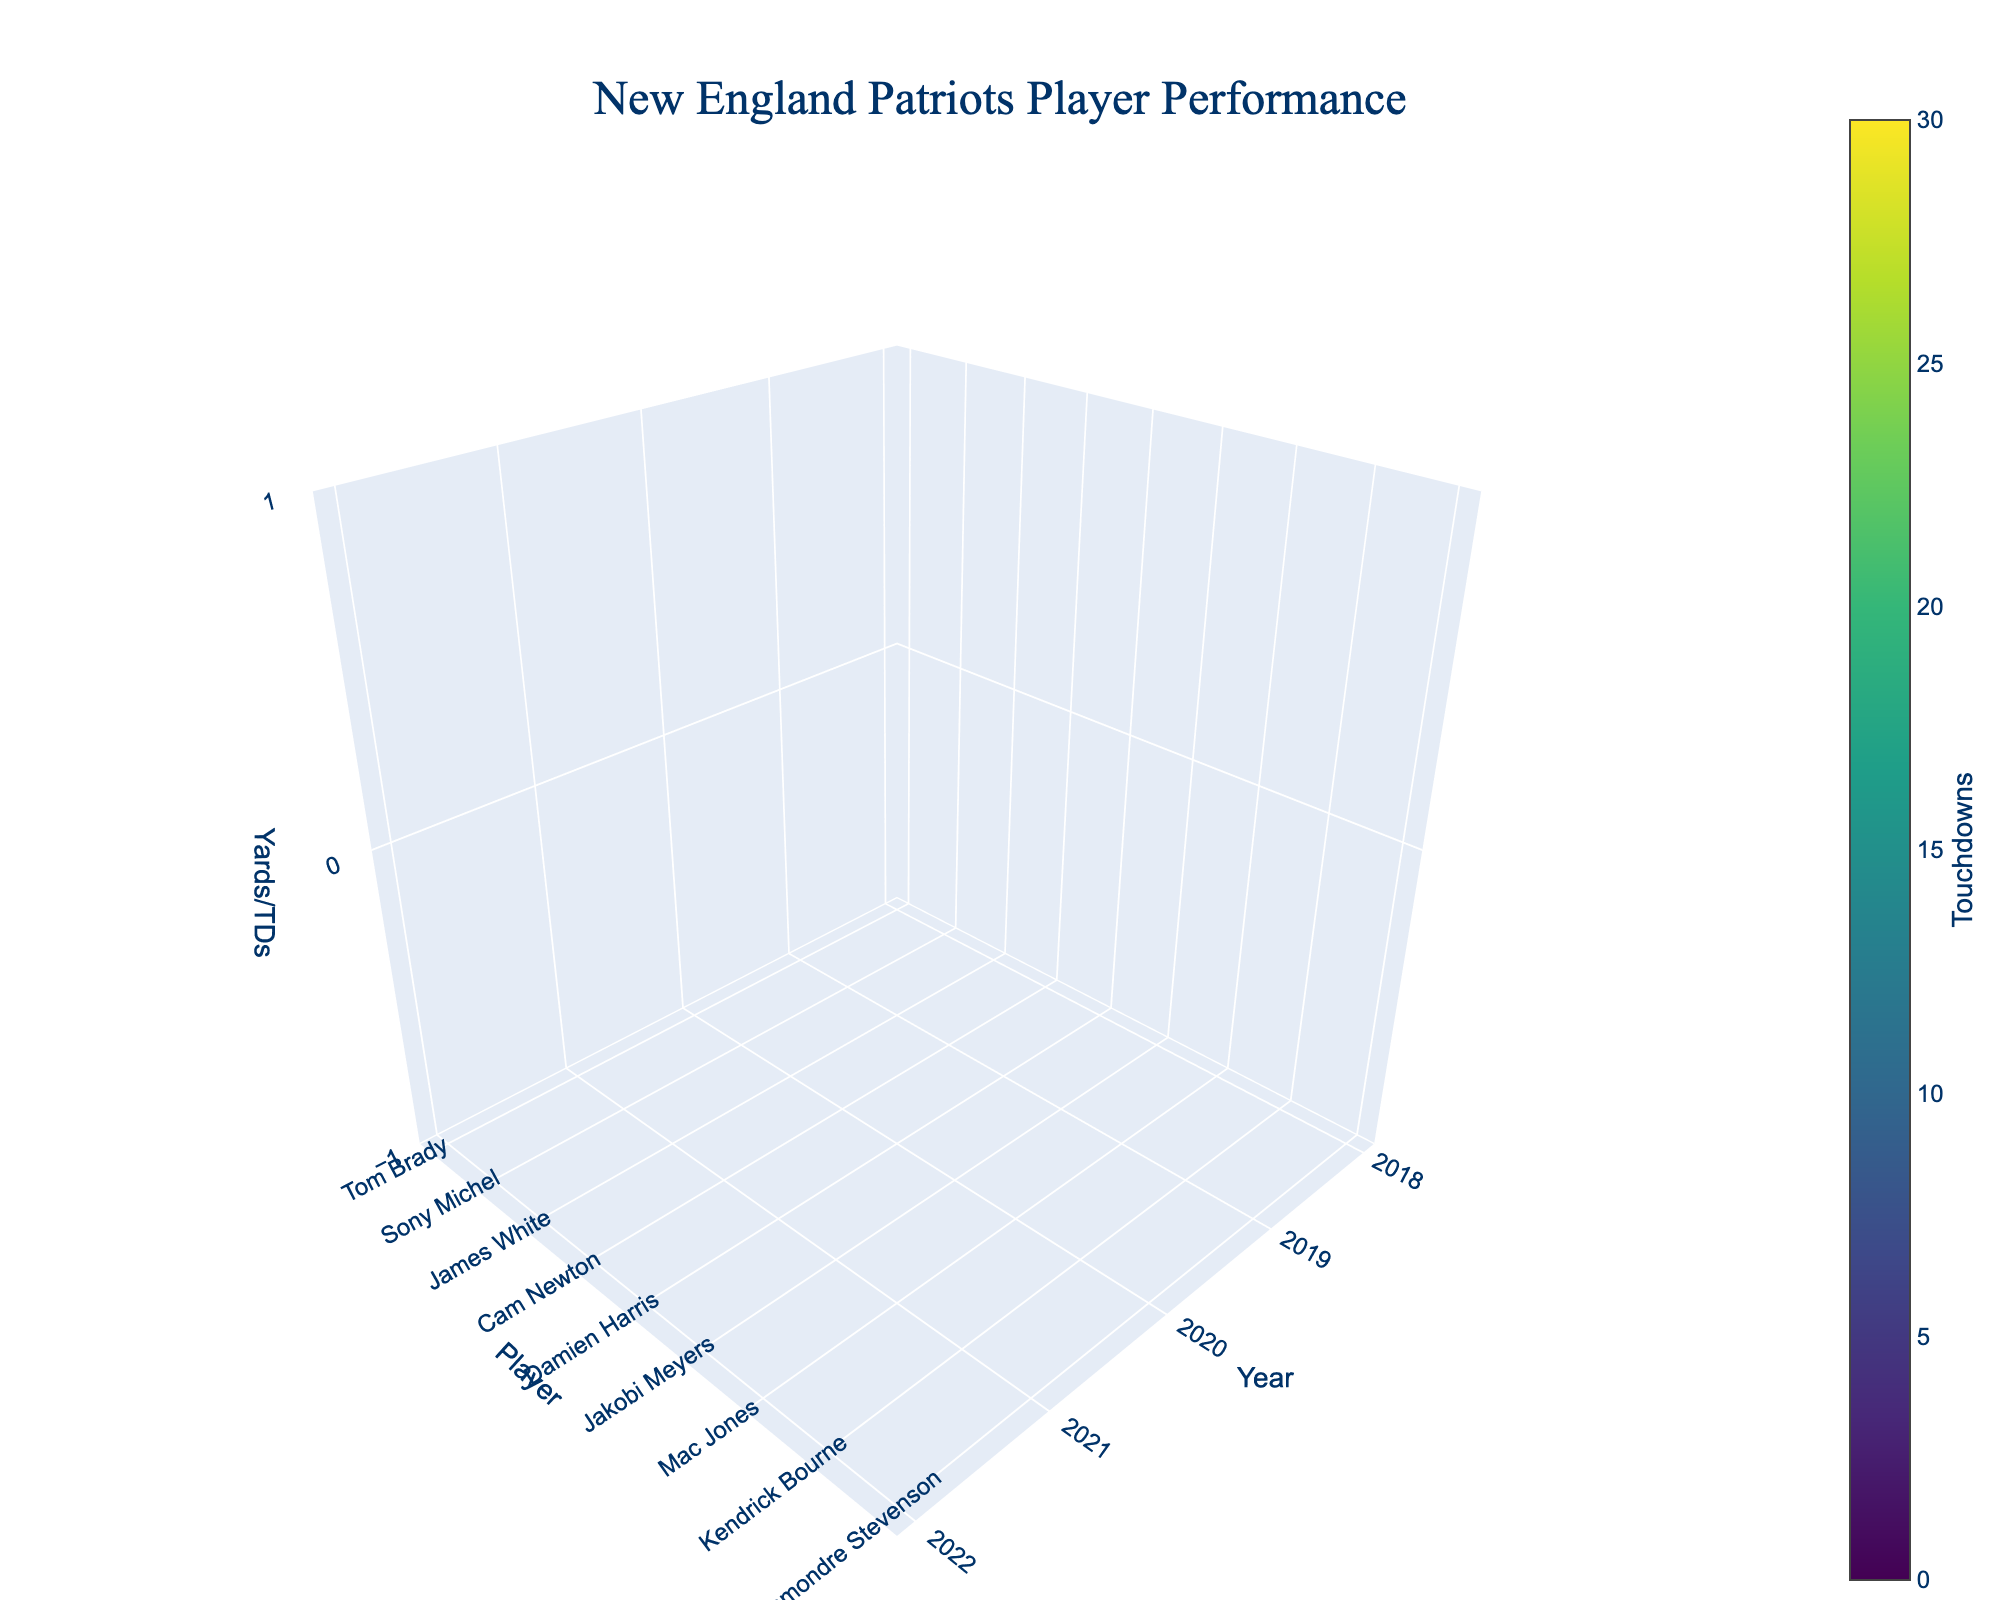What is the title of the figure? The title is typically displayed at the top of the figure. In this case, it would mention "New England Patriots Player Performance."
Answer: New England Patriots Player Performance Which player had the highest rushing yards in 2022? Locate the 2022 data points on the plot. Then identify the player with the highest value on the 'rushing yards' axis.
Answer: Rhamondre Stevenson How did Tom Brady's passing yards change from 2018 to 2019? Compare the values of Tom Brady's passing yards for the years 2018 and 2019. Check the relevant points for these years on the plot.
Answer: Decreased Which player scored the most touchdowns in 2021? Check the plot for the 2021 data points and identify which player's touchdowns value is the highest.
Answer: Damien Harris Who had more total yards (passing + rushing) in 2020, Cam Newton or Damien Harris? Sum the passing and rushing yards for both players in 2020. Cam Newton: 2657 (passing) + 592 (rushing) = 3249. Damien Harris: 691 (rushing).
Answer: Cam Newton Which year had the highest average number of touchdowns across all players? Calculate the average number of touchdowns for each year by summing the touchdowns of all players in that year and dividing by the number of players. Compare these averages across the years.
Answer: 2018 What are the axis titles in the figure? Axis titles can usually be identified by checking the labels along the axes. They would be 'Year', 'Player', and 'Yards/TDs'.
Answer: Year, Player, Yards/TDs Did any player have zeros for all metrics in any given year? Investigate the data points to see if any player has zero passing yards, rushing yards, and touchdowns for any year.
Answer: No Who had more touchdowns in 2019, Tom Brady or James White? Locate the 2019 data points for Tom Brady and James White and compare their touchdown values.
Answer: Tom Brady 